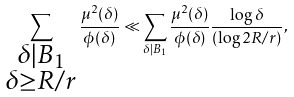Convert formula to latex. <formula><loc_0><loc_0><loc_500><loc_500>\sum _ { \substack { \delta | B _ { 1 } \\ \delta \geq R / r } } \frac { \mu ^ { 2 } ( \delta ) } { \phi ( \delta ) } \ll \sum _ { \delta | B _ { 1 } } \frac { \mu ^ { 2 } ( \delta ) } { \phi ( \delta ) } \frac { \log \delta } { ( \log 2 R / r ) } ,</formula> 